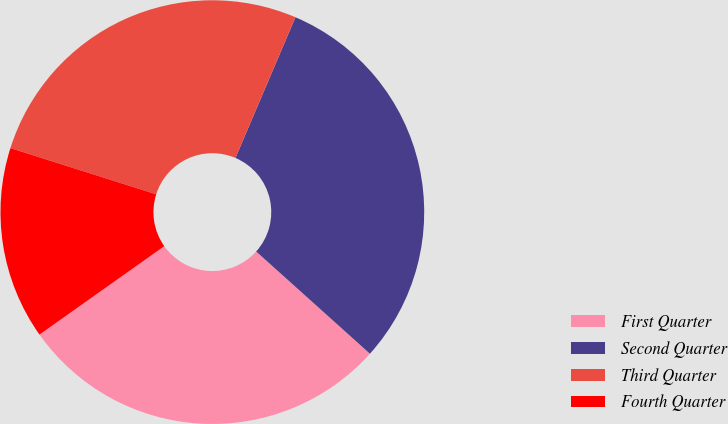Convert chart. <chart><loc_0><loc_0><loc_500><loc_500><pie_chart><fcel>First Quarter<fcel>Second Quarter<fcel>Third Quarter<fcel>Fourth Quarter<nl><fcel>28.54%<fcel>30.24%<fcel>26.53%<fcel>14.7%<nl></chart> 